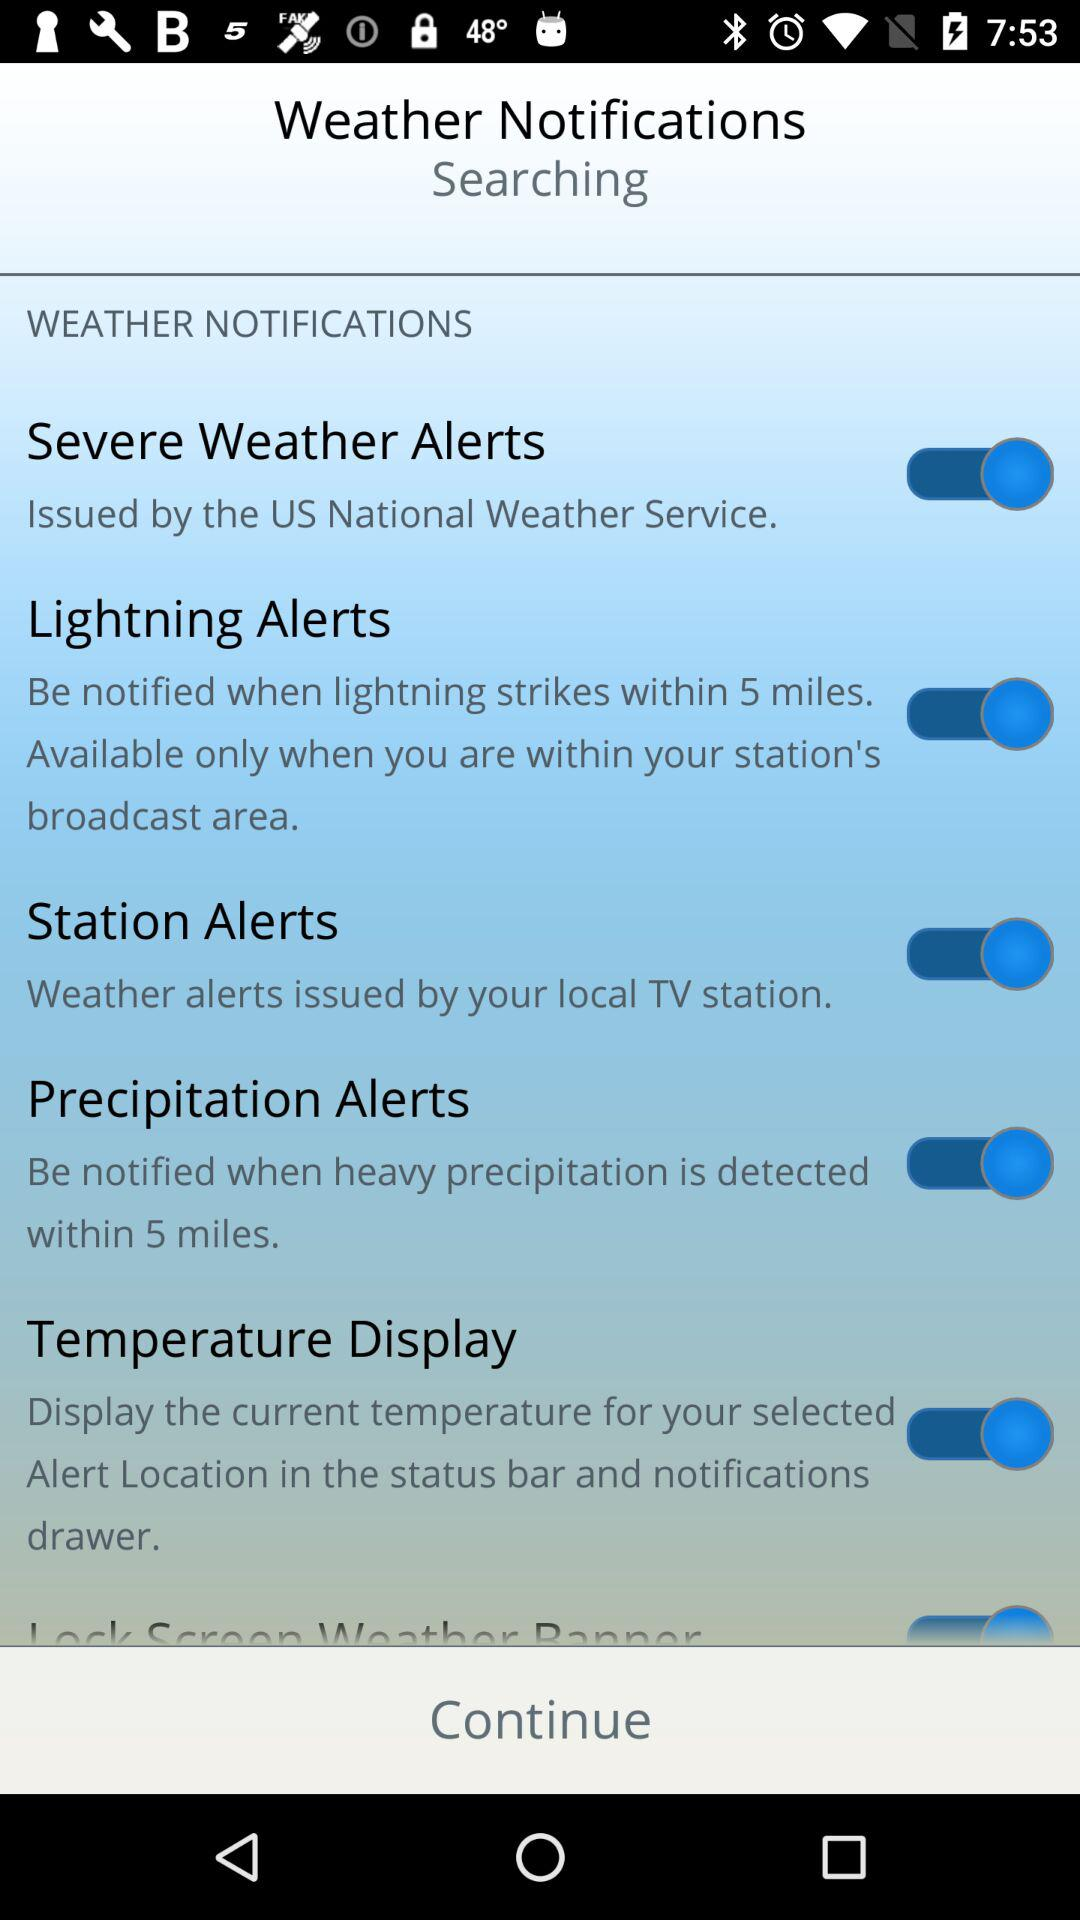Who issues the severe weather alerts? The severe weather alerts are issued by the "US National Weather Service". 